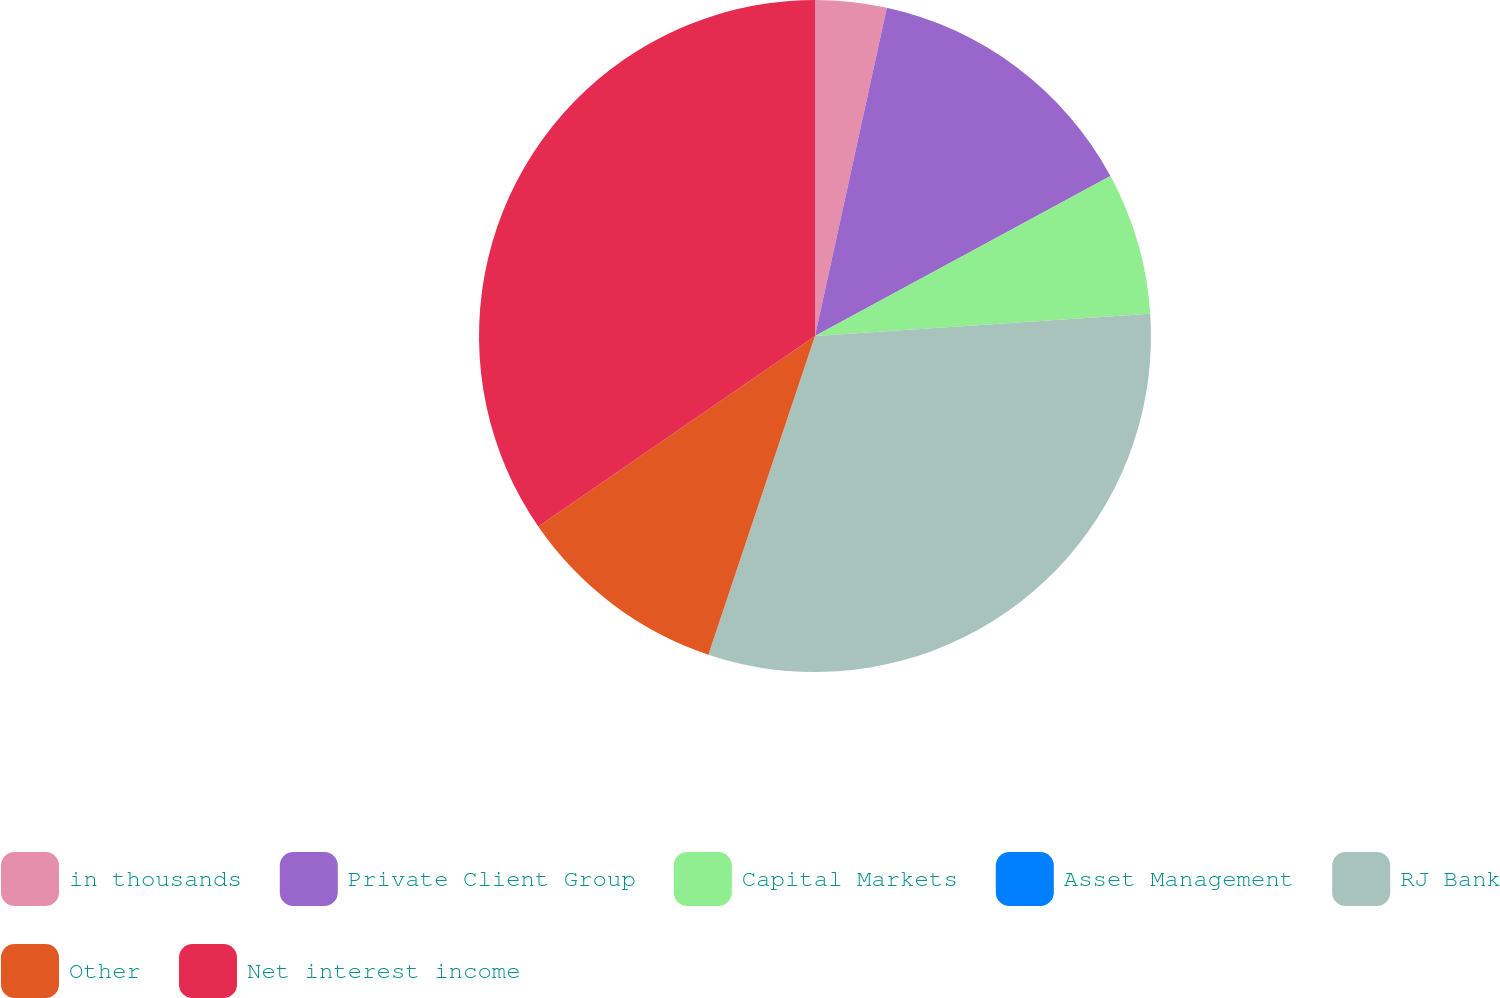Convert chart. <chart><loc_0><loc_0><loc_500><loc_500><pie_chart><fcel>in thousands<fcel>Private Client Group<fcel>Capital Markets<fcel>Asset Management<fcel>RJ Bank<fcel>Other<fcel>Net interest income<nl><fcel>3.43%<fcel>13.67%<fcel>6.84%<fcel>0.01%<fcel>31.19%<fcel>10.26%<fcel>34.6%<nl></chart> 